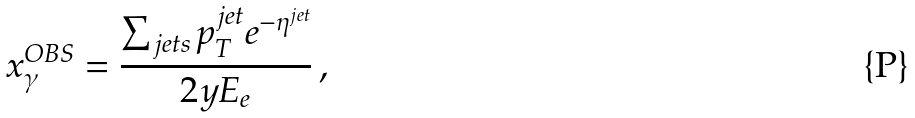<formula> <loc_0><loc_0><loc_500><loc_500>x _ { \gamma } ^ { O B S } = \frac { \sum _ { j e t s } p _ { T } ^ { j e t } e ^ { - \eta ^ { j e t } } } { 2 y E _ { e } } \, ,</formula> 